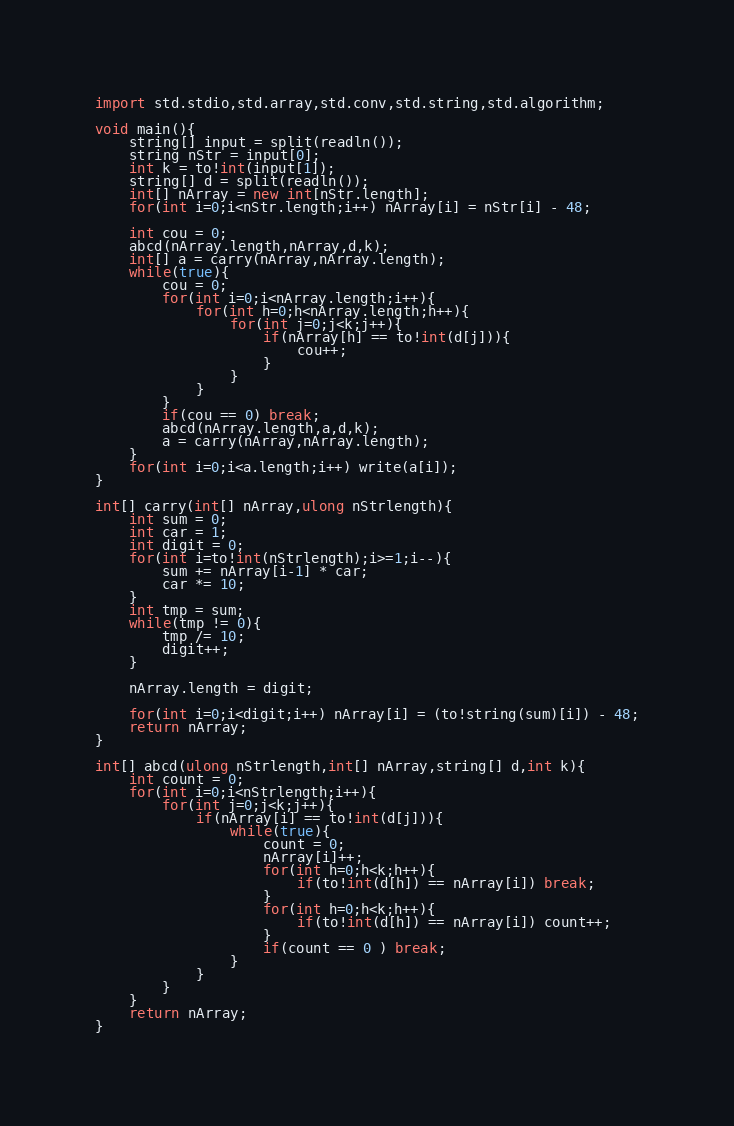Convert code to text. <code><loc_0><loc_0><loc_500><loc_500><_D_>import std.stdio,std.array,std.conv,std.string,std.algorithm;

void main(){
    string[] input = split(readln());
    string nStr = input[0];
    int k = to!int(input[1]);
    string[] d = split(readln());
    int[] nArray = new int[nStr.length];
    for(int i=0;i<nStr.length;i++) nArray[i] = nStr[i] - 48;

    int cou = 0;
    abcd(nArray.length,nArray,d,k);
    int[] a = carry(nArray,nArray.length);
    while(true){
        cou = 0;
        for(int i=0;i<nArray.length;i++){
            for(int h=0;h<nArray.length;h++){
                for(int j=0;j<k;j++){
                    if(nArray[h] == to!int(d[j])){
                        cou++;
                    }
                }
            }
        }
        if(cou == 0) break;
        abcd(nArray.length,a,d,k);
        a = carry(nArray,nArray.length);
    }
    for(int i=0;i<a.length;i++) write(a[i]);
}

int[] carry(int[] nArray,ulong nStrlength){
    int sum = 0;
    int car = 1;
    int digit = 0;
    for(int i=to!int(nStrlength);i>=1;i--){
        sum += nArray[i-1] * car;
        car *= 10; 
    }
    int tmp = sum;
    while(tmp != 0){
        tmp /= 10;
        digit++;
    }

    nArray.length = digit;

    for(int i=0;i<digit;i++) nArray[i] = (to!string(sum)[i]) - 48;
    return nArray;
}

int[] abcd(ulong nStrlength,int[] nArray,string[] d,int k){
    int count = 0;
    for(int i=0;i<nStrlength;i++){
        for(int j=0;j<k;j++){
            if(nArray[i] == to!int(d[j])){
                while(true){
                    count = 0;
                    nArray[i]++;
                    for(int h=0;h<k;h++){
                        if(to!int(d[h]) == nArray[i]) break;
                    }
                    for(int h=0;h<k;h++){
                        if(to!int(d[h]) == nArray[i]) count++;
                    }
                    if(count == 0 ) break;
                }
            }
        }
    }
    return nArray;
}
</code> 